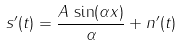Convert formula to latex. <formula><loc_0><loc_0><loc_500><loc_500>s ^ { \prime } ( t ) = \frac { A \, \sin ( \alpha x ) } { \alpha } + n ^ { \prime } ( t )</formula> 